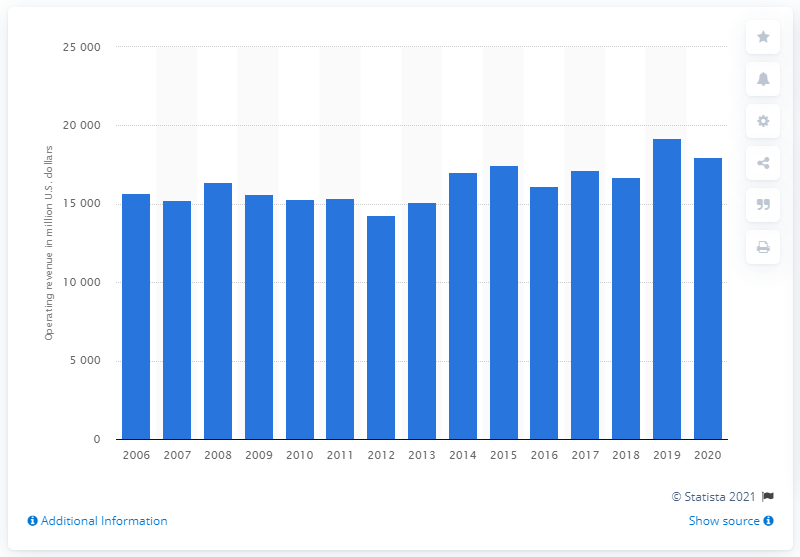Specify some key components in this picture. NextEra Energy generated approximately $179.97 billion in revenue in 2020. In 2020, NextEra Energy's operating revenue was approximately 19,204 dollars. 